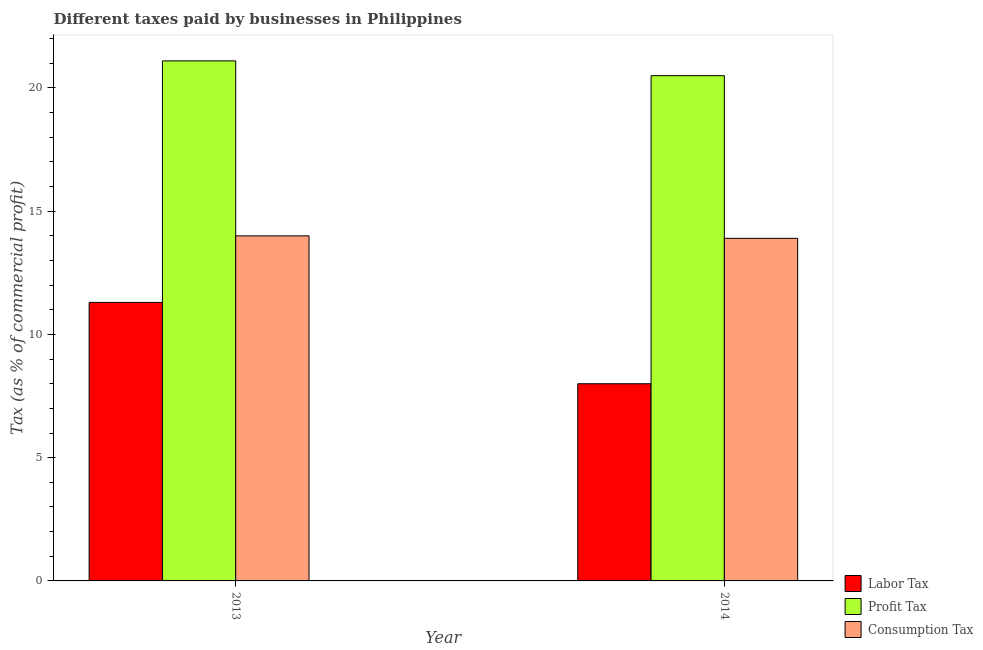How many different coloured bars are there?
Keep it short and to the point. 3. Are the number of bars on each tick of the X-axis equal?
Keep it short and to the point. Yes. How many bars are there on the 1st tick from the left?
Provide a short and direct response. 3. What is the label of the 2nd group of bars from the left?
Offer a terse response. 2014. What is the percentage of labor tax in 2013?
Your answer should be compact. 11.3. Across all years, what is the maximum percentage of consumption tax?
Give a very brief answer. 14. In which year was the percentage of labor tax maximum?
Provide a succinct answer. 2013. In which year was the percentage of consumption tax minimum?
Ensure brevity in your answer.  2014. What is the total percentage of profit tax in the graph?
Provide a short and direct response. 41.6. What is the difference between the percentage of consumption tax in 2013 and that in 2014?
Your response must be concise. 0.1. What is the difference between the percentage of consumption tax in 2013 and the percentage of labor tax in 2014?
Your answer should be very brief. 0.1. What is the average percentage of labor tax per year?
Your response must be concise. 9.65. In how many years, is the percentage of labor tax greater than 13 %?
Give a very brief answer. 0. What is the ratio of the percentage of labor tax in 2013 to that in 2014?
Provide a short and direct response. 1.41. In how many years, is the percentage of labor tax greater than the average percentage of labor tax taken over all years?
Ensure brevity in your answer.  1. What does the 1st bar from the left in 2013 represents?
Your answer should be very brief. Labor Tax. What does the 1st bar from the right in 2014 represents?
Provide a succinct answer. Consumption Tax. Are all the bars in the graph horizontal?
Ensure brevity in your answer.  No. How many years are there in the graph?
Offer a terse response. 2. What is the difference between two consecutive major ticks on the Y-axis?
Provide a short and direct response. 5. Does the graph contain any zero values?
Make the answer very short. No. Does the graph contain grids?
Keep it short and to the point. No. Where does the legend appear in the graph?
Provide a succinct answer. Bottom right. How many legend labels are there?
Give a very brief answer. 3. What is the title of the graph?
Provide a short and direct response. Different taxes paid by businesses in Philippines. Does "Ages 20-50" appear as one of the legend labels in the graph?
Provide a short and direct response. No. What is the label or title of the Y-axis?
Provide a succinct answer. Tax (as % of commercial profit). What is the Tax (as % of commercial profit) in Profit Tax in 2013?
Your answer should be very brief. 21.1. What is the Tax (as % of commercial profit) of Labor Tax in 2014?
Offer a terse response. 8. Across all years, what is the maximum Tax (as % of commercial profit) of Labor Tax?
Provide a succinct answer. 11.3. Across all years, what is the maximum Tax (as % of commercial profit) of Profit Tax?
Offer a terse response. 21.1. Across all years, what is the maximum Tax (as % of commercial profit) in Consumption Tax?
Provide a short and direct response. 14. Across all years, what is the minimum Tax (as % of commercial profit) of Labor Tax?
Provide a succinct answer. 8. What is the total Tax (as % of commercial profit) in Labor Tax in the graph?
Your answer should be very brief. 19.3. What is the total Tax (as % of commercial profit) of Profit Tax in the graph?
Offer a very short reply. 41.6. What is the total Tax (as % of commercial profit) in Consumption Tax in the graph?
Offer a very short reply. 27.9. What is the difference between the Tax (as % of commercial profit) in Profit Tax in 2013 and that in 2014?
Offer a terse response. 0.6. What is the difference between the Tax (as % of commercial profit) of Labor Tax in 2013 and the Tax (as % of commercial profit) of Profit Tax in 2014?
Give a very brief answer. -9.2. What is the difference between the Tax (as % of commercial profit) of Labor Tax in 2013 and the Tax (as % of commercial profit) of Consumption Tax in 2014?
Your answer should be compact. -2.6. What is the difference between the Tax (as % of commercial profit) in Profit Tax in 2013 and the Tax (as % of commercial profit) in Consumption Tax in 2014?
Your response must be concise. 7.2. What is the average Tax (as % of commercial profit) of Labor Tax per year?
Provide a short and direct response. 9.65. What is the average Tax (as % of commercial profit) of Profit Tax per year?
Your answer should be very brief. 20.8. What is the average Tax (as % of commercial profit) in Consumption Tax per year?
Give a very brief answer. 13.95. In the year 2013, what is the difference between the Tax (as % of commercial profit) in Labor Tax and Tax (as % of commercial profit) in Profit Tax?
Offer a terse response. -9.8. What is the ratio of the Tax (as % of commercial profit) of Labor Tax in 2013 to that in 2014?
Your answer should be compact. 1.41. What is the ratio of the Tax (as % of commercial profit) of Profit Tax in 2013 to that in 2014?
Offer a very short reply. 1.03. What is the ratio of the Tax (as % of commercial profit) of Consumption Tax in 2013 to that in 2014?
Provide a short and direct response. 1.01. What is the difference between the highest and the second highest Tax (as % of commercial profit) of Labor Tax?
Your response must be concise. 3.3. What is the difference between the highest and the lowest Tax (as % of commercial profit) of Profit Tax?
Provide a short and direct response. 0.6. What is the difference between the highest and the lowest Tax (as % of commercial profit) of Consumption Tax?
Give a very brief answer. 0.1. 